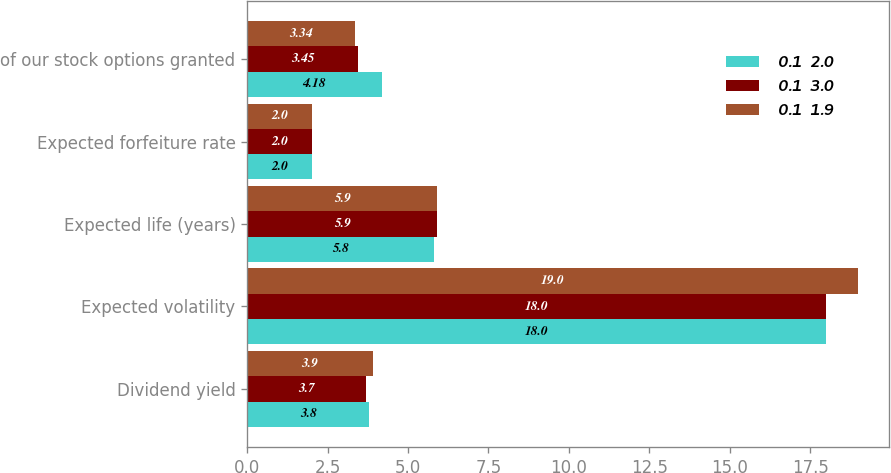Convert chart. <chart><loc_0><loc_0><loc_500><loc_500><stacked_bar_chart><ecel><fcel>Dividend yield<fcel>Expected volatility<fcel>Expected life (years)<fcel>Expected forfeiture rate<fcel>of our stock options granted<nl><fcel>0.1  2.0<fcel>3.8<fcel>18<fcel>5.8<fcel>2<fcel>4.18<nl><fcel>0.1  3.0<fcel>3.7<fcel>18<fcel>5.9<fcel>2<fcel>3.45<nl><fcel>0.1  1.9<fcel>3.9<fcel>19<fcel>5.9<fcel>2<fcel>3.34<nl></chart> 